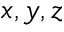<formula> <loc_0><loc_0><loc_500><loc_500>x , y , z</formula> 